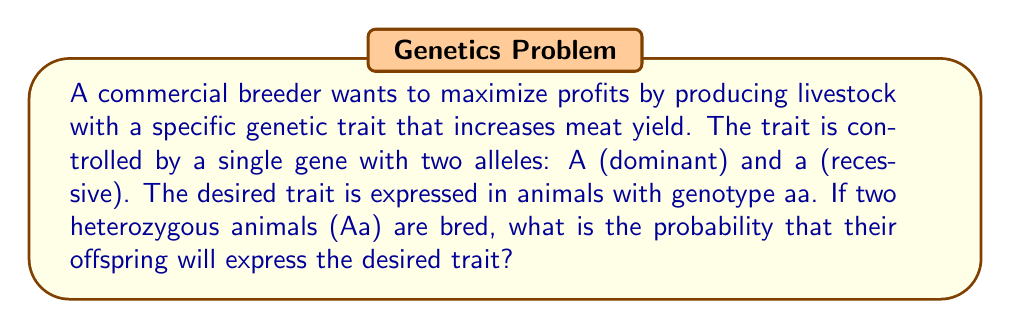Teach me how to tackle this problem. To solve this problem, we need to follow these steps:

1. Identify the genotypes of the parent animals:
   Both parents are heterozygous (Aa)

2. Determine possible gamete combinations:
   Each parent can produce gametes with either A or a allele

3. Use a Punnett square to visualize possible offspring genotypes:

   $$
   \begin{array}{c|c|c}
    & A & a \\
   \hline
   A & AA & Aa \\
   \hline
   a & Aa & aa \\
   \end{array}
   $$

4. Count the number of offspring with the desired genotype (aa):
   There is 1 aa genotype out of 4 possible outcomes

5. Calculate the probability:
   $$P(\text{desired trait}) = \frac{\text{favorable outcomes}}{\text{total outcomes}} = \frac{1}{4} = 0.25 = 25\%$$

Therefore, the probability of producing an offspring with the desired trait (aa genotype) from two heterozygous parents is 1/4 or 25%.
Answer: $\frac{1}{4}$ or $25\%$ 